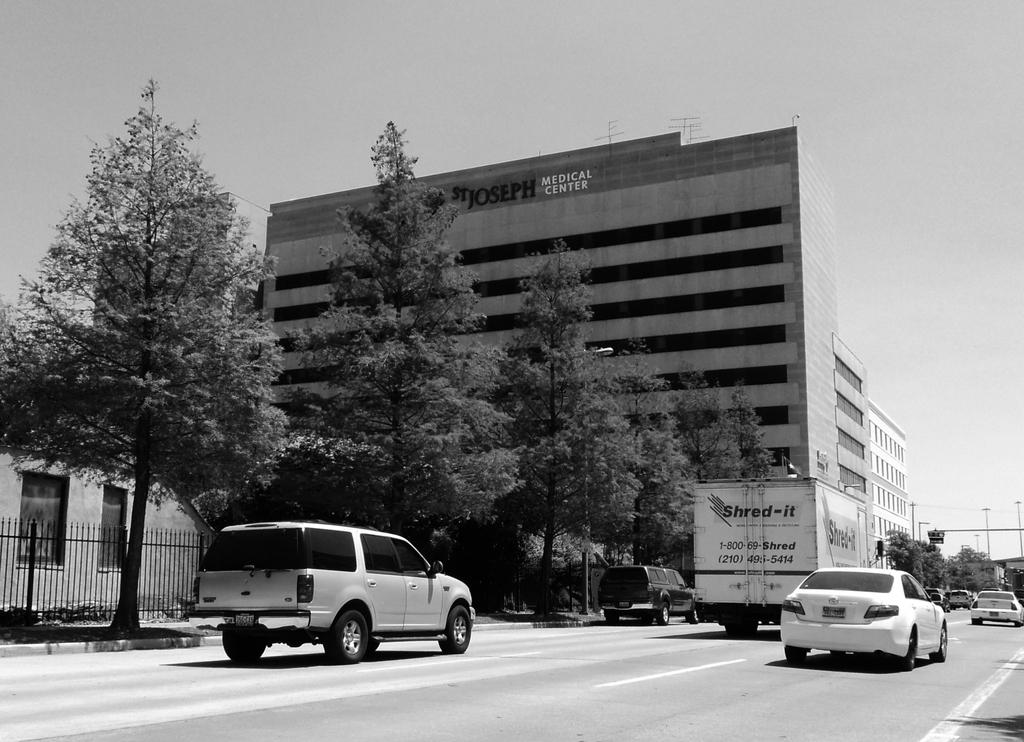What is happening in the foreground of the image? There are vehicles moving on the road in the foreground of the image. What can be seen in the background of the image? There are trees, railing, buildings, and poles in the background of the image. What is visible at the top of the image? The sky is visible at the top of the image. What is the name of the banana in the image? There is no banana present in the image. Can you tell me how many times the person in the image takes a bite of the banana? There is no person or banana present in the image. 